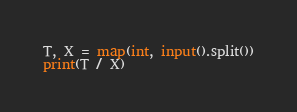<code> <loc_0><loc_0><loc_500><loc_500><_Python_>T, X = map(int, input().split())
print(T / X)</code> 